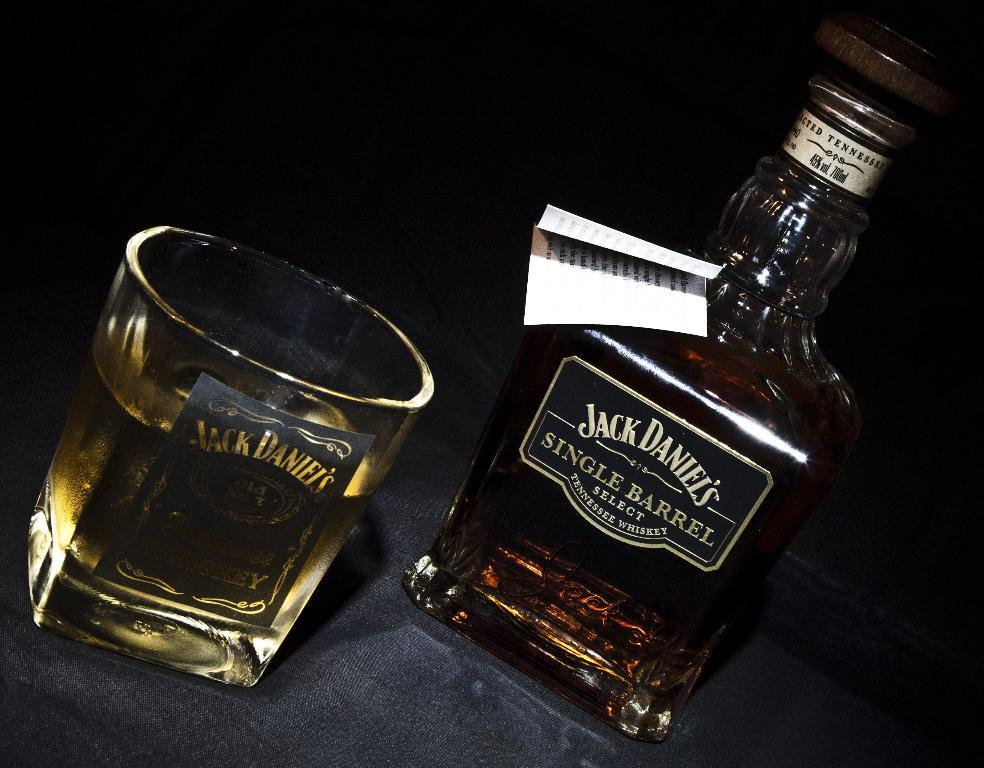Provide a one-sentence caption for the provided image. A bottle of Jack Daniels whiskey on a table next to a glass filled with the liquor. 